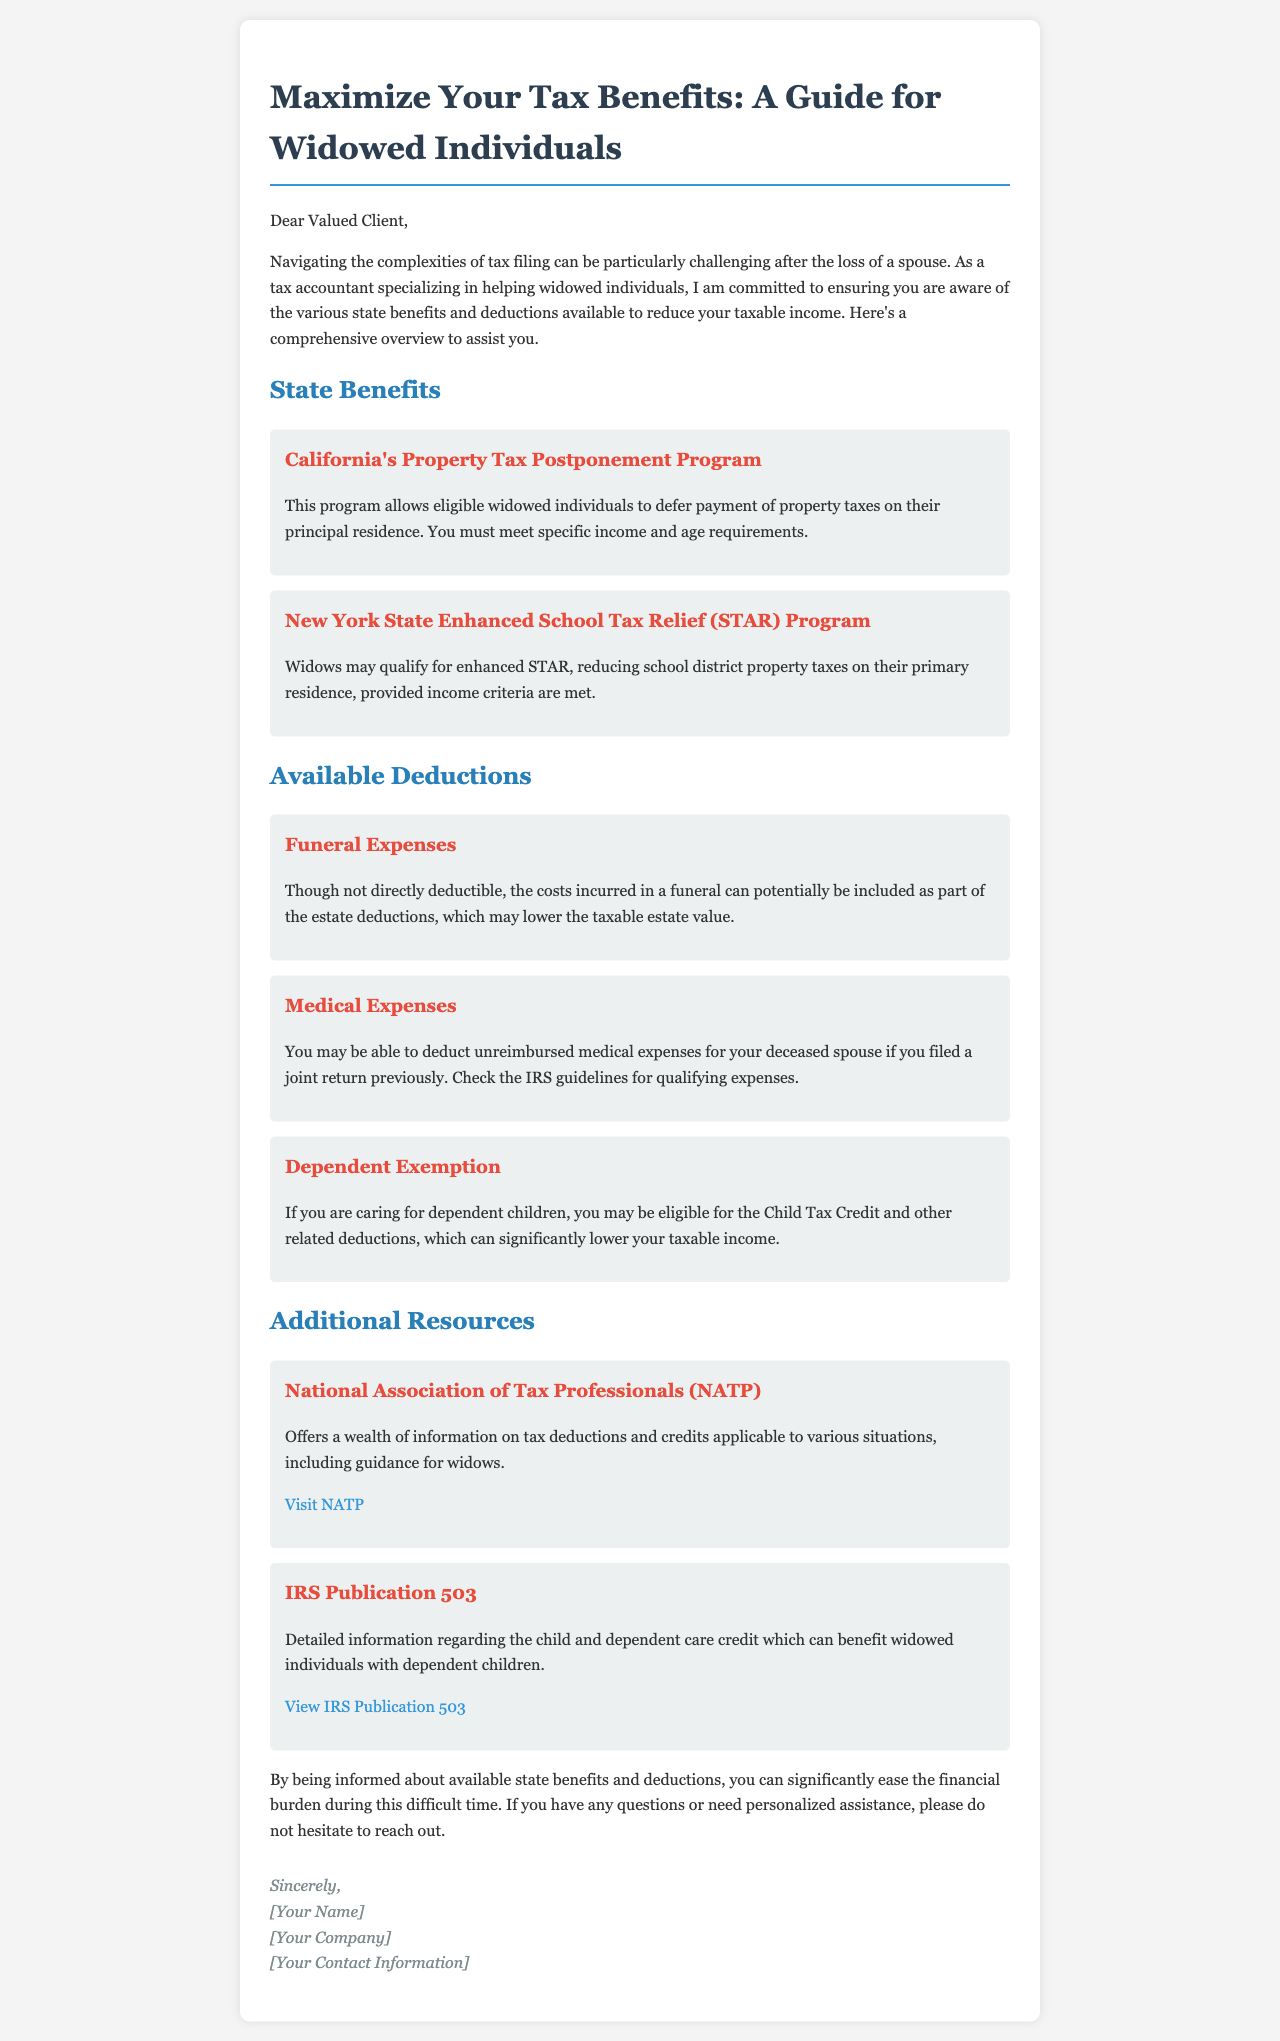What program allows deferring property taxes for widowed individuals in California? The document specifies the California's Property Tax Postponement Program as a benefit for eligible widowed individuals.
Answer: California's Property Tax Postponement Program What is one way to potentially reduce the taxable estate value after a spouse's funeral? The document mentions that funeral expenses can be included as part of the estate deductions which may lower the taxable estate value.
Answer: Estate deductions What credit may you be eligible for if you are caring for dependent children? The Child Tax Credit is mentioned as a potential credit for those caring for dependent children.
Answer: Child Tax Credit Which IRS publication contains information on the child and dependent care credit? The document references IRS Publication 503 for detailed information regarding the child and dependent care credit.
Answer: IRS Publication 503 What is one eligibility requirement for New York State's STAR Program? The document indicates that widows may qualify for enhanced STAR based on meeting income criteria.
Answer: Income criteria What type of expenses can be deducted if they are unreimbursed for a deceased spouse? The document describes that unreimbursed medical expenses for a deceased spouse can potentially be deducted if a joint return was filed previously.
Answer: Medical expenses What organization offers information on tax deductions applicable to various situations, including guidance for widows? The National Association of Tax Professionals (NATP) is mentioned as an organization providing information on tax deductions.
Answer: National Association of Tax Professionals What age and income requirements must be met for property tax deferral in California? The document states that specific income and age requirements must be met to qualify for the California's Property Tax Postponement Program.
Answer: Specific income and age requirements What should you do if you have questions or need personalized assistance regarding tax benefits? The document encourages reaching out for personalized assistance if you have questions about tax benefits.
Answer: Reach out for assistance 